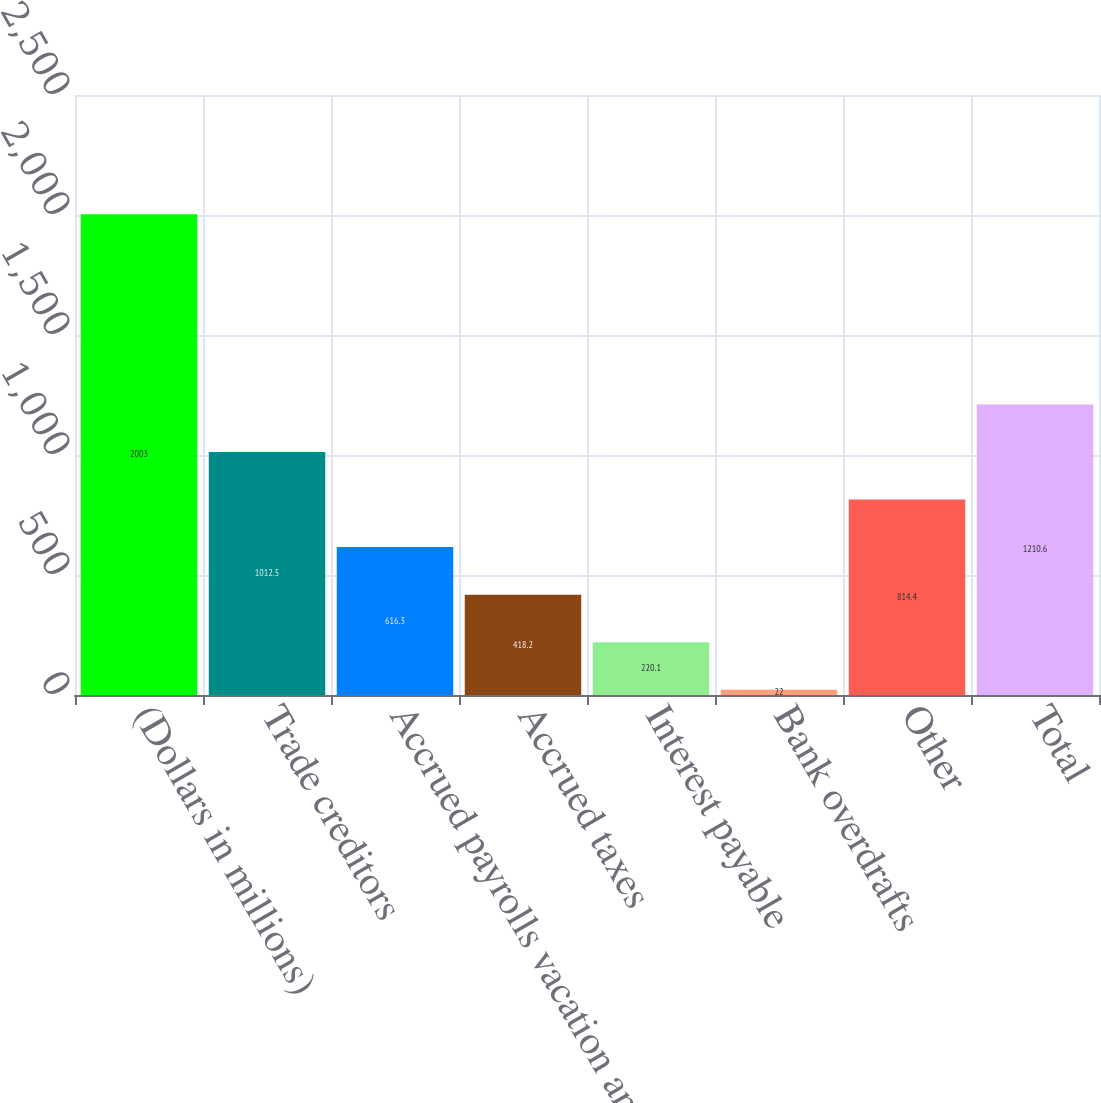Convert chart to OTSL. <chart><loc_0><loc_0><loc_500><loc_500><bar_chart><fcel>(Dollars in millions)<fcel>Trade creditors<fcel>Accrued payrolls vacation and<fcel>Accrued taxes<fcel>Interest payable<fcel>Bank overdrafts<fcel>Other<fcel>Total<nl><fcel>2003<fcel>1012.5<fcel>616.3<fcel>418.2<fcel>220.1<fcel>22<fcel>814.4<fcel>1210.6<nl></chart> 